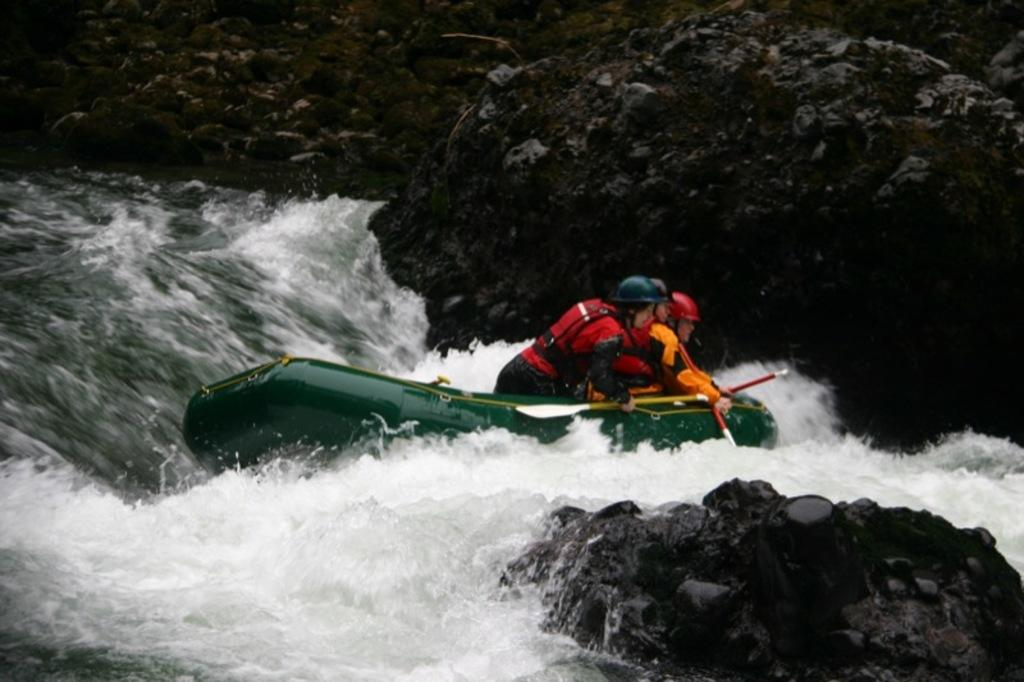How many people are in the image? A: There are three men in the image. What are the men wearing? The men are wearing red safety jackets. What are the men sitting in? The men are sitting in an inflatable boat. What type of water can be seen in the image? There is river water visible in the image. What is visible in the background of the image? There is a rock mountain in the background of the image. What type of hobbies do the cows in the image enjoy? There are no cows present in the image, so it is not possible to determine their hobbies. 